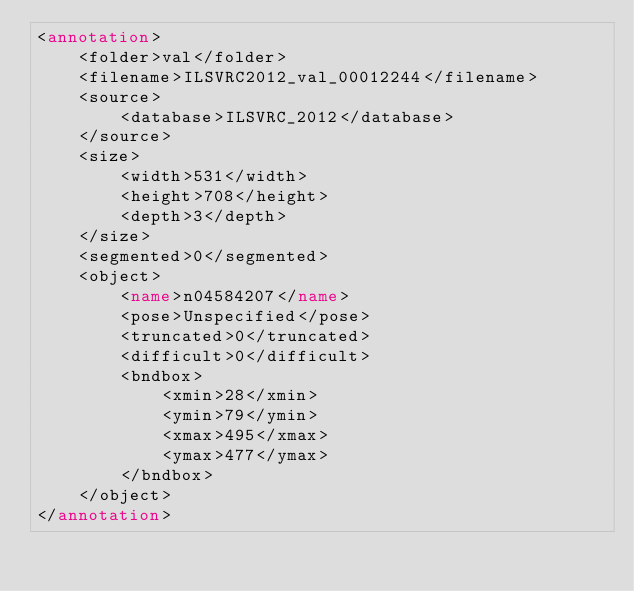Convert code to text. <code><loc_0><loc_0><loc_500><loc_500><_XML_><annotation>
	<folder>val</folder>
	<filename>ILSVRC2012_val_00012244</filename>
	<source>
		<database>ILSVRC_2012</database>
	</source>
	<size>
		<width>531</width>
		<height>708</height>
		<depth>3</depth>
	</size>
	<segmented>0</segmented>
	<object>
		<name>n04584207</name>
		<pose>Unspecified</pose>
		<truncated>0</truncated>
		<difficult>0</difficult>
		<bndbox>
			<xmin>28</xmin>
			<ymin>79</ymin>
			<xmax>495</xmax>
			<ymax>477</ymax>
		</bndbox>
	</object>
</annotation></code> 